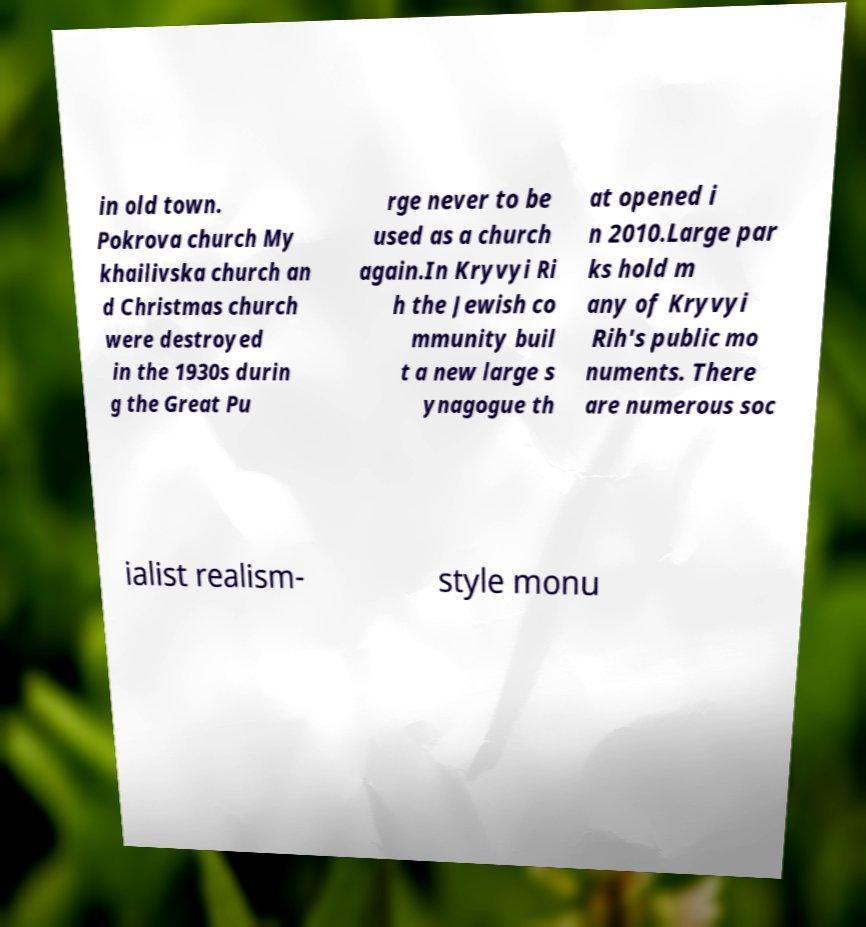Please read and relay the text visible in this image. What does it say? in old town. Pokrova church My khailivska church an d Christmas church were destroyed in the 1930s durin g the Great Pu rge never to be used as a church again.In Kryvyi Ri h the Jewish co mmunity buil t a new large s ynagogue th at opened i n 2010.Large par ks hold m any of Kryvyi Rih's public mo numents. There are numerous soc ialist realism- style monu 